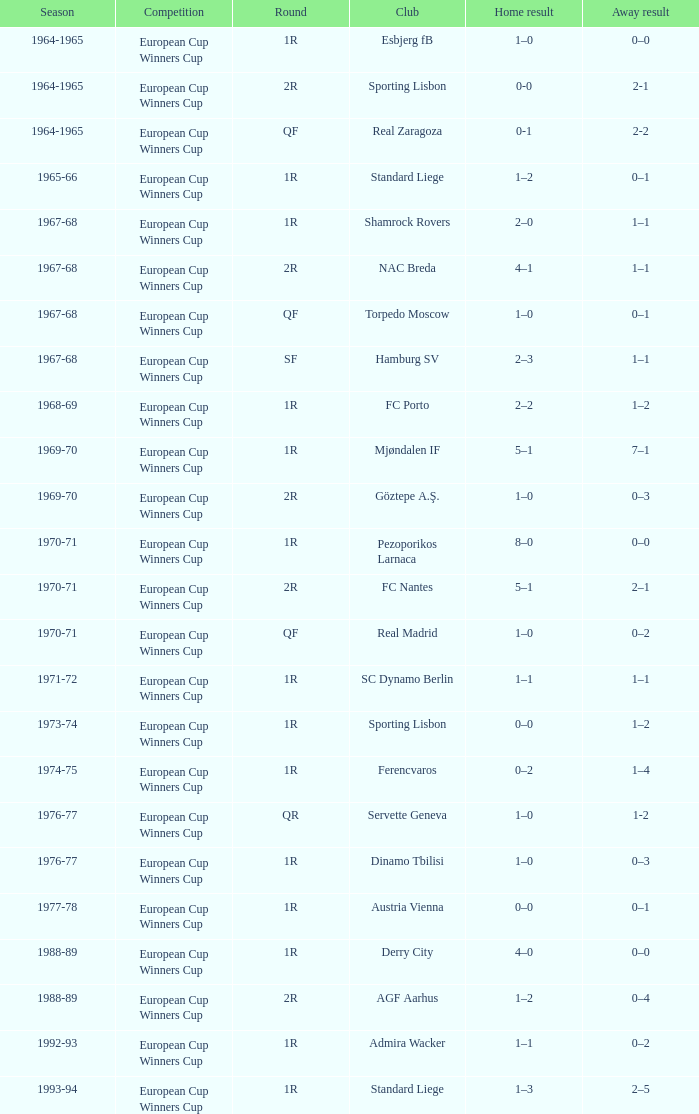In which season does a 1st round and an away score of 7-1 occur? 1969-70. 